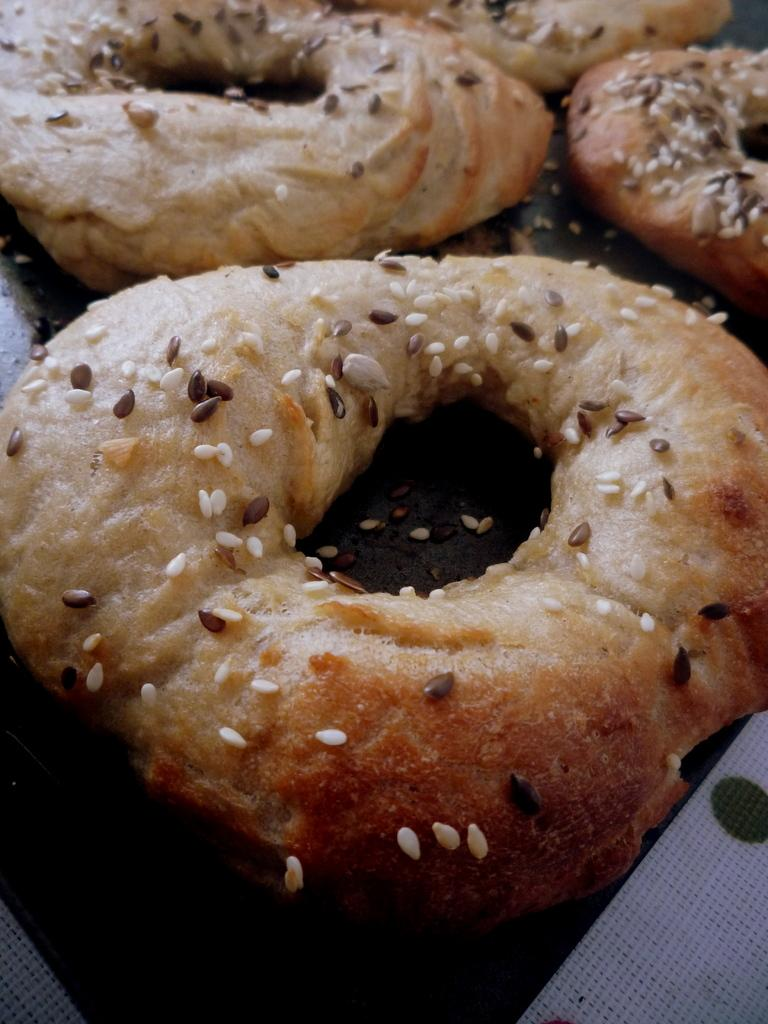What type of objects are present in the image? There are food items in the image. Where are the food items located? The food items are on a platform. Can you see any docks in the image? There is no dock present in the image. What type of trees are visible in the image? There is no mention of trees in the provided facts, so it cannot be determined if any trees are visible in the image. 